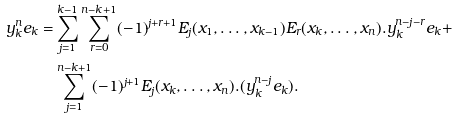<formula> <loc_0><loc_0><loc_500><loc_500>y _ { k } ^ { n } e _ { k } = & \sum _ { j = 1 } ^ { k - 1 } \sum _ { r = 0 } ^ { n - k + 1 } ( - 1 ) ^ { j + r + 1 } E _ { j } ( x _ { 1 } , \dots , x _ { k - 1 } ) E _ { r } ( x _ { k } , \dots , x _ { n } ) . y _ { k } ^ { n - j - r } e _ { k } + \\ & \sum _ { j = 1 } ^ { n - k + 1 } ( - 1 ) ^ { j + 1 } E _ { j } ( x _ { k } , \dots , x _ { n } ) . ( y _ { k } ^ { n - j } e _ { k } ) .</formula> 